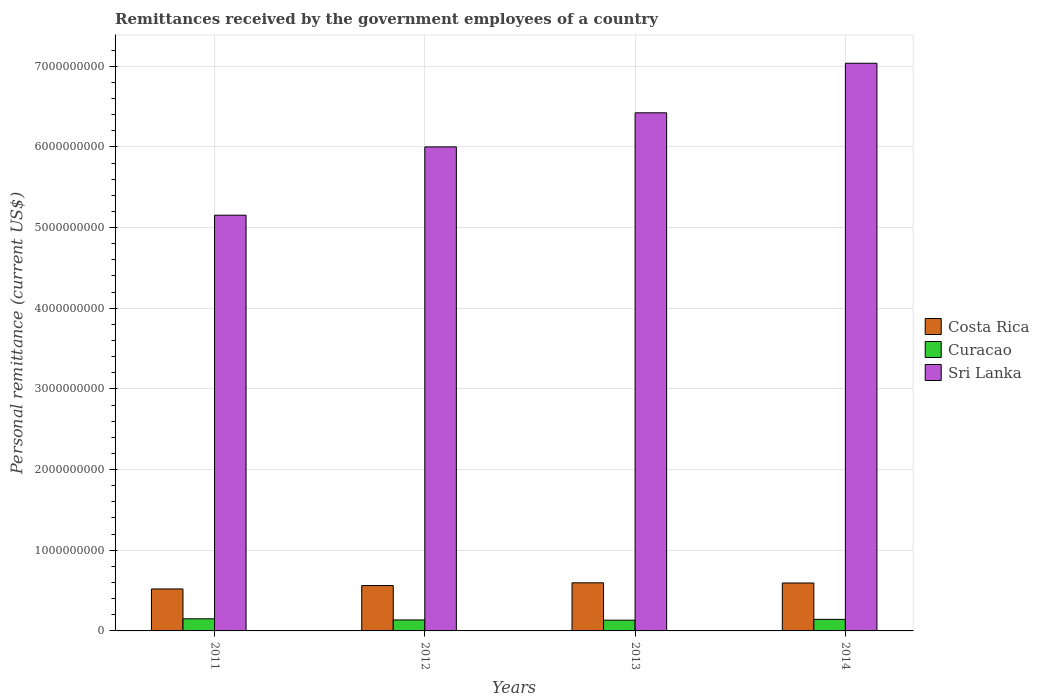How many groups of bars are there?
Your answer should be very brief. 4. Are the number of bars per tick equal to the number of legend labels?
Provide a succinct answer. Yes. How many bars are there on the 1st tick from the left?
Make the answer very short. 3. How many bars are there on the 3rd tick from the right?
Provide a short and direct response. 3. What is the label of the 4th group of bars from the left?
Offer a very short reply. 2014. In how many cases, is the number of bars for a given year not equal to the number of legend labels?
Your response must be concise. 0. What is the remittances received by the government employees in Curacao in 2011?
Offer a very short reply. 1.50e+08. Across all years, what is the maximum remittances received by the government employees in Curacao?
Offer a very short reply. 1.50e+08. Across all years, what is the minimum remittances received by the government employees in Costa Rica?
Provide a succinct answer. 5.20e+08. What is the total remittances received by the government employees in Costa Rica in the graph?
Offer a very short reply. 2.27e+09. What is the difference between the remittances received by the government employees in Costa Rica in 2012 and that in 2013?
Offer a terse response. -3.41e+07. What is the difference between the remittances received by the government employees in Sri Lanka in 2011 and the remittances received by the government employees in Curacao in 2013?
Your answer should be very brief. 5.02e+09. What is the average remittances received by the government employees in Sri Lanka per year?
Offer a terse response. 6.15e+09. In the year 2011, what is the difference between the remittances received by the government employees in Curacao and remittances received by the government employees in Costa Rica?
Give a very brief answer. -3.70e+08. In how many years, is the remittances received by the government employees in Sri Lanka greater than 7000000000 US$?
Provide a succinct answer. 1. What is the ratio of the remittances received by the government employees in Costa Rica in 2013 to that in 2014?
Your answer should be compact. 1. What is the difference between the highest and the second highest remittances received by the government employees in Costa Rica?
Ensure brevity in your answer.  2.47e+06. What is the difference between the highest and the lowest remittances received by the government employees in Sri Lanka?
Your answer should be compact. 1.88e+09. What does the 2nd bar from the left in 2012 represents?
Make the answer very short. Curacao. What does the 2nd bar from the right in 2012 represents?
Your answer should be compact. Curacao. Is it the case that in every year, the sum of the remittances received by the government employees in Costa Rica and remittances received by the government employees in Sri Lanka is greater than the remittances received by the government employees in Curacao?
Offer a terse response. Yes. Are all the bars in the graph horizontal?
Offer a very short reply. No. How many years are there in the graph?
Your answer should be very brief. 4. Are the values on the major ticks of Y-axis written in scientific E-notation?
Provide a short and direct response. No. Does the graph contain any zero values?
Offer a terse response. No. Does the graph contain grids?
Offer a terse response. Yes. How many legend labels are there?
Provide a short and direct response. 3. How are the legend labels stacked?
Provide a short and direct response. Vertical. What is the title of the graph?
Keep it short and to the point. Remittances received by the government employees of a country. What is the label or title of the Y-axis?
Your answer should be very brief. Personal remittance (current US$). What is the Personal remittance (current US$) of Costa Rica in 2011?
Provide a short and direct response. 5.20e+08. What is the Personal remittance (current US$) in Curacao in 2011?
Keep it short and to the point. 1.50e+08. What is the Personal remittance (current US$) in Sri Lanka in 2011?
Make the answer very short. 5.15e+09. What is the Personal remittance (current US$) in Costa Rica in 2012?
Offer a terse response. 5.62e+08. What is the Personal remittance (current US$) in Curacao in 2012?
Offer a very short reply. 1.36e+08. What is the Personal remittance (current US$) in Sri Lanka in 2012?
Offer a terse response. 6.00e+09. What is the Personal remittance (current US$) in Costa Rica in 2013?
Provide a succinct answer. 5.96e+08. What is the Personal remittance (current US$) of Curacao in 2013?
Provide a short and direct response. 1.33e+08. What is the Personal remittance (current US$) of Sri Lanka in 2013?
Your answer should be very brief. 6.42e+09. What is the Personal remittance (current US$) of Costa Rica in 2014?
Ensure brevity in your answer.  5.94e+08. What is the Personal remittance (current US$) of Curacao in 2014?
Make the answer very short. 1.43e+08. What is the Personal remittance (current US$) in Sri Lanka in 2014?
Your answer should be very brief. 7.04e+09. Across all years, what is the maximum Personal remittance (current US$) in Costa Rica?
Make the answer very short. 5.96e+08. Across all years, what is the maximum Personal remittance (current US$) of Curacao?
Give a very brief answer. 1.50e+08. Across all years, what is the maximum Personal remittance (current US$) in Sri Lanka?
Your answer should be very brief. 7.04e+09. Across all years, what is the minimum Personal remittance (current US$) of Costa Rica?
Offer a terse response. 5.20e+08. Across all years, what is the minimum Personal remittance (current US$) in Curacao?
Keep it short and to the point. 1.33e+08. Across all years, what is the minimum Personal remittance (current US$) of Sri Lanka?
Your response must be concise. 5.15e+09. What is the total Personal remittance (current US$) of Costa Rica in the graph?
Offer a terse response. 2.27e+09. What is the total Personal remittance (current US$) in Curacao in the graph?
Provide a succinct answer. 5.62e+08. What is the total Personal remittance (current US$) of Sri Lanka in the graph?
Keep it short and to the point. 2.46e+1. What is the difference between the Personal remittance (current US$) of Costa Rica in 2011 and that in 2012?
Provide a short and direct response. -4.21e+07. What is the difference between the Personal remittance (current US$) in Curacao in 2011 and that in 2012?
Offer a very short reply. 1.42e+07. What is the difference between the Personal remittance (current US$) of Sri Lanka in 2011 and that in 2012?
Make the answer very short. -8.47e+08. What is the difference between the Personal remittance (current US$) of Costa Rica in 2011 and that in 2013?
Make the answer very short. -7.62e+07. What is the difference between the Personal remittance (current US$) of Curacao in 2011 and that in 2013?
Provide a succinct answer. 1.71e+07. What is the difference between the Personal remittance (current US$) in Sri Lanka in 2011 and that in 2013?
Ensure brevity in your answer.  -1.27e+09. What is the difference between the Personal remittance (current US$) in Costa Rica in 2011 and that in 2014?
Provide a succinct answer. -7.37e+07. What is the difference between the Personal remittance (current US$) of Curacao in 2011 and that in 2014?
Make the answer very short. 6.85e+06. What is the difference between the Personal remittance (current US$) in Sri Lanka in 2011 and that in 2014?
Ensure brevity in your answer.  -1.88e+09. What is the difference between the Personal remittance (current US$) in Costa Rica in 2012 and that in 2013?
Your answer should be compact. -3.41e+07. What is the difference between the Personal remittance (current US$) of Curacao in 2012 and that in 2013?
Provide a short and direct response. 2.91e+06. What is the difference between the Personal remittance (current US$) of Sri Lanka in 2012 and that in 2013?
Offer a very short reply. -4.23e+08. What is the difference between the Personal remittance (current US$) of Costa Rica in 2012 and that in 2014?
Keep it short and to the point. -3.16e+07. What is the difference between the Personal remittance (current US$) of Curacao in 2012 and that in 2014?
Your answer should be compact. -7.31e+06. What is the difference between the Personal remittance (current US$) in Sri Lanka in 2012 and that in 2014?
Give a very brief answer. -1.04e+09. What is the difference between the Personal remittance (current US$) of Costa Rica in 2013 and that in 2014?
Keep it short and to the point. 2.47e+06. What is the difference between the Personal remittance (current US$) in Curacao in 2013 and that in 2014?
Provide a succinct answer. -1.02e+07. What is the difference between the Personal remittance (current US$) of Sri Lanka in 2013 and that in 2014?
Provide a succinct answer. -6.14e+08. What is the difference between the Personal remittance (current US$) in Costa Rica in 2011 and the Personal remittance (current US$) in Curacao in 2012?
Your answer should be very brief. 3.84e+08. What is the difference between the Personal remittance (current US$) of Costa Rica in 2011 and the Personal remittance (current US$) of Sri Lanka in 2012?
Provide a succinct answer. -5.48e+09. What is the difference between the Personal remittance (current US$) in Curacao in 2011 and the Personal remittance (current US$) in Sri Lanka in 2012?
Your response must be concise. -5.85e+09. What is the difference between the Personal remittance (current US$) in Costa Rica in 2011 and the Personal remittance (current US$) in Curacao in 2013?
Make the answer very short. 3.87e+08. What is the difference between the Personal remittance (current US$) of Costa Rica in 2011 and the Personal remittance (current US$) of Sri Lanka in 2013?
Make the answer very short. -5.90e+09. What is the difference between the Personal remittance (current US$) of Curacao in 2011 and the Personal remittance (current US$) of Sri Lanka in 2013?
Your answer should be compact. -6.27e+09. What is the difference between the Personal remittance (current US$) in Costa Rica in 2011 and the Personal remittance (current US$) in Curacao in 2014?
Offer a terse response. 3.77e+08. What is the difference between the Personal remittance (current US$) in Costa Rica in 2011 and the Personal remittance (current US$) in Sri Lanka in 2014?
Your answer should be very brief. -6.52e+09. What is the difference between the Personal remittance (current US$) of Curacao in 2011 and the Personal remittance (current US$) of Sri Lanka in 2014?
Your answer should be very brief. -6.89e+09. What is the difference between the Personal remittance (current US$) in Costa Rica in 2012 and the Personal remittance (current US$) in Curacao in 2013?
Keep it short and to the point. 4.29e+08. What is the difference between the Personal remittance (current US$) in Costa Rica in 2012 and the Personal remittance (current US$) in Sri Lanka in 2013?
Make the answer very short. -5.86e+09. What is the difference between the Personal remittance (current US$) of Curacao in 2012 and the Personal remittance (current US$) of Sri Lanka in 2013?
Offer a very short reply. -6.29e+09. What is the difference between the Personal remittance (current US$) in Costa Rica in 2012 and the Personal remittance (current US$) in Curacao in 2014?
Provide a short and direct response. 4.19e+08. What is the difference between the Personal remittance (current US$) in Costa Rica in 2012 and the Personal remittance (current US$) in Sri Lanka in 2014?
Provide a short and direct response. -6.47e+09. What is the difference between the Personal remittance (current US$) in Curacao in 2012 and the Personal remittance (current US$) in Sri Lanka in 2014?
Offer a very short reply. -6.90e+09. What is the difference between the Personal remittance (current US$) in Costa Rica in 2013 and the Personal remittance (current US$) in Curacao in 2014?
Offer a very short reply. 4.53e+08. What is the difference between the Personal remittance (current US$) in Costa Rica in 2013 and the Personal remittance (current US$) in Sri Lanka in 2014?
Your response must be concise. -6.44e+09. What is the difference between the Personal remittance (current US$) in Curacao in 2013 and the Personal remittance (current US$) in Sri Lanka in 2014?
Ensure brevity in your answer.  -6.90e+09. What is the average Personal remittance (current US$) in Costa Rica per year?
Ensure brevity in your answer.  5.68e+08. What is the average Personal remittance (current US$) of Curacao per year?
Give a very brief answer. 1.41e+08. What is the average Personal remittance (current US$) of Sri Lanka per year?
Offer a terse response. 6.15e+09. In the year 2011, what is the difference between the Personal remittance (current US$) of Costa Rica and Personal remittance (current US$) of Curacao?
Give a very brief answer. 3.70e+08. In the year 2011, what is the difference between the Personal remittance (current US$) of Costa Rica and Personal remittance (current US$) of Sri Lanka?
Provide a short and direct response. -4.63e+09. In the year 2011, what is the difference between the Personal remittance (current US$) of Curacao and Personal remittance (current US$) of Sri Lanka?
Give a very brief answer. -5.00e+09. In the year 2012, what is the difference between the Personal remittance (current US$) in Costa Rica and Personal remittance (current US$) in Curacao?
Keep it short and to the point. 4.26e+08. In the year 2012, what is the difference between the Personal remittance (current US$) of Costa Rica and Personal remittance (current US$) of Sri Lanka?
Your answer should be very brief. -5.44e+09. In the year 2012, what is the difference between the Personal remittance (current US$) in Curacao and Personal remittance (current US$) in Sri Lanka?
Offer a terse response. -5.86e+09. In the year 2013, what is the difference between the Personal remittance (current US$) in Costa Rica and Personal remittance (current US$) in Curacao?
Your answer should be very brief. 4.63e+08. In the year 2013, what is the difference between the Personal remittance (current US$) of Costa Rica and Personal remittance (current US$) of Sri Lanka?
Your answer should be very brief. -5.83e+09. In the year 2013, what is the difference between the Personal remittance (current US$) of Curacao and Personal remittance (current US$) of Sri Lanka?
Provide a short and direct response. -6.29e+09. In the year 2014, what is the difference between the Personal remittance (current US$) in Costa Rica and Personal remittance (current US$) in Curacao?
Provide a succinct answer. 4.51e+08. In the year 2014, what is the difference between the Personal remittance (current US$) of Costa Rica and Personal remittance (current US$) of Sri Lanka?
Your response must be concise. -6.44e+09. In the year 2014, what is the difference between the Personal remittance (current US$) of Curacao and Personal remittance (current US$) of Sri Lanka?
Keep it short and to the point. -6.89e+09. What is the ratio of the Personal remittance (current US$) in Costa Rica in 2011 to that in 2012?
Give a very brief answer. 0.93. What is the ratio of the Personal remittance (current US$) of Curacao in 2011 to that in 2012?
Keep it short and to the point. 1.1. What is the ratio of the Personal remittance (current US$) of Sri Lanka in 2011 to that in 2012?
Your response must be concise. 0.86. What is the ratio of the Personal remittance (current US$) in Costa Rica in 2011 to that in 2013?
Keep it short and to the point. 0.87. What is the ratio of the Personal remittance (current US$) in Curacao in 2011 to that in 2013?
Give a very brief answer. 1.13. What is the ratio of the Personal remittance (current US$) in Sri Lanka in 2011 to that in 2013?
Your answer should be very brief. 0.8. What is the ratio of the Personal remittance (current US$) of Costa Rica in 2011 to that in 2014?
Provide a succinct answer. 0.88. What is the ratio of the Personal remittance (current US$) in Curacao in 2011 to that in 2014?
Ensure brevity in your answer.  1.05. What is the ratio of the Personal remittance (current US$) of Sri Lanka in 2011 to that in 2014?
Offer a very short reply. 0.73. What is the ratio of the Personal remittance (current US$) in Costa Rica in 2012 to that in 2013?
Your response must be concise. 0.94. What is the ratio of the Personal remittance (current US$) in Curacao in 2012 to that in 2013?
Make the answer very short. 1.02. What is the ratio of the Personal remittance (current US$) in Sri Lanka in 2012 to that in 2013?
Offer a very short reply. 0.93. What is the ratio of the Personal remittance (current US$) in Costa Rica in 2012 to that in 2014?
Keep it short and to the point. 0.95. What is the ratio of the Personal remittance (current US$) in Curacao in 2012 to that in 2014?
Offer a very short reply. 0.95. What is the ratio of the Personal remittance (current US$) in Sri Lanka in 2012 to that in 2014?
Offer a terse response. 0.85. What is the ratio of the Personal remittance (current US$) in Curacao in 2013 to that in 2014?
Your response must be concise. 0.93. What is the ratio of the Personal remittance (current US$) of Sri Lanka in 2013 to that in 2014?
Offer a terse response. 0.91. What is the difference between the highest and the second highest Personal remittance (current US$) in Costa Rica?
Offer a very short reply. 2.47e+06. What is the difference between the highest and the second highest Personal remittance (current US$) in Curacao?
Give a very brief answer. 6.85e+06. What is the difference between the highest and the second highest Personal remittance (current US$) of Sri Lanka?
Make the answer very short. 6.14e+08. What is the difference between the highest and the lowest Personal remittance (current US$) of Costa Rica?
Your answer should be compact. 7.62e+07. What is the difference between the highest and the lowest Personal remittance (current US$) in Curacao?
Keep it short and to the point. 1.71e+07. What is the difference between the highest and the lowest Personal remittance (current US$) of Sri Lanka?
Offer a very short reply. 1.88e+09. 